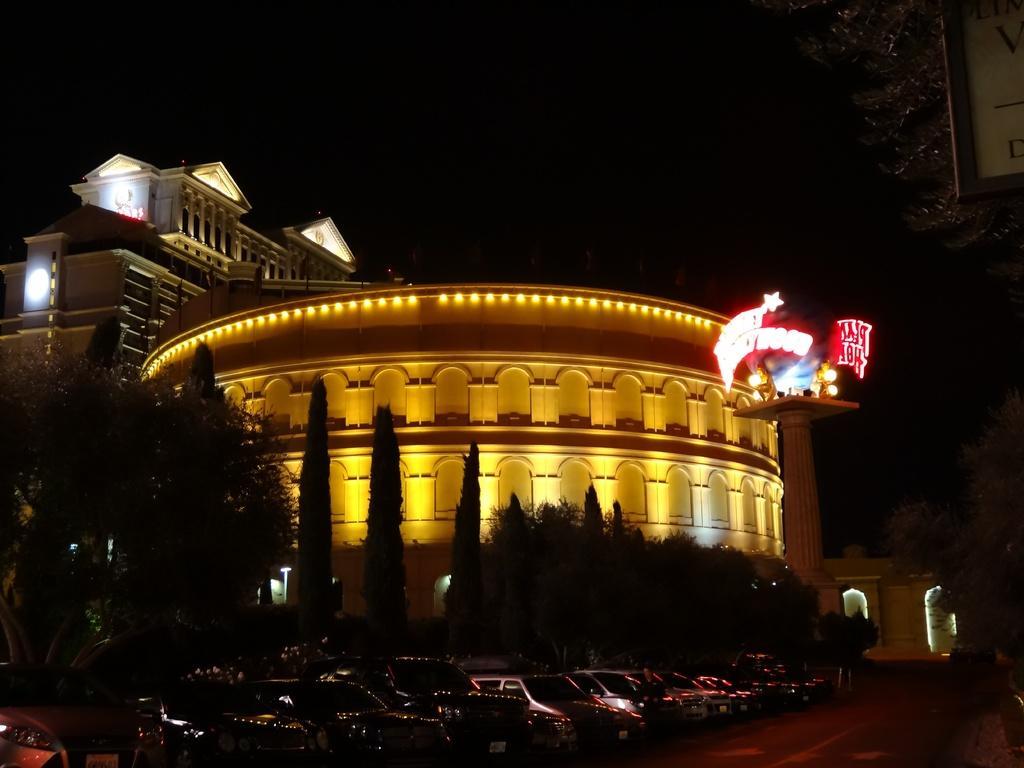Can you describe this image briefly? In this picture there are buildings and trees. In the foreground there are vehicles on the road and there are boards on the buildings. On the right side of the image there is a text on the board. At the top there is sky. At the bottom there is a road. 